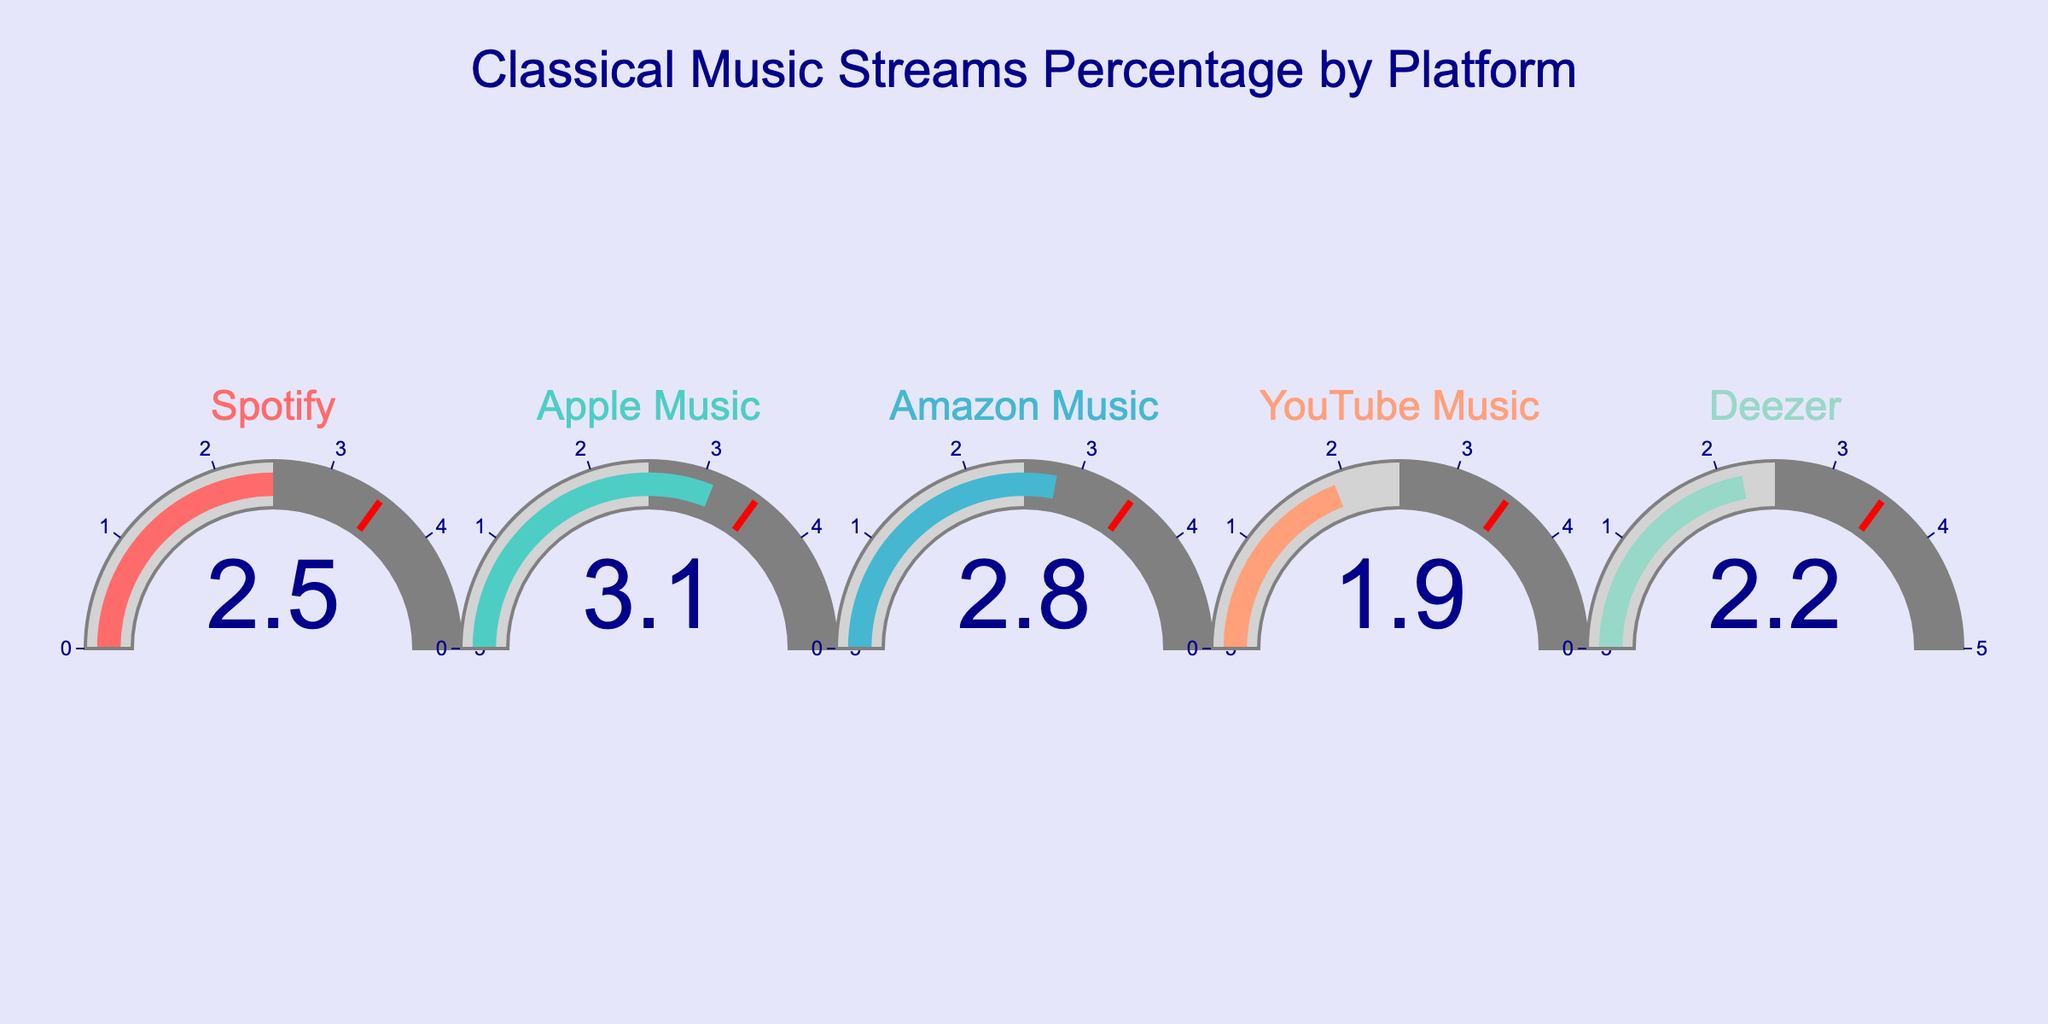what is the title of the figure? The title of the figure is located at the top center, and it clearly states the purpose of the visualization.
Answer: "Classical Music Streams Percentage by Platform" How many platforms are displayed in the figure? The figure contains gauges for individual platforms, each representing classical music stream percentages. You can count them one by one.
Answer: 5 Which platform has the highest percentage of classical music streams? Look at the numbers shown in each gauge. Identify the platform with the highest value.
Answer: Apple Music How much lower is the classical music stream percentage on YouTube Music compared to Apple Music? Find and compare the percentages of YouTube Music and Apple Music. Subtract the YouTube Music percentage from that of Apple Music.
Answer: 1.2% Is there any platform where classical music streams percentage exceeds 3%? Check all gauges to see if any percentage value is greater than 3%.
Answer: Yes, Apple Music What is the overall range of classical music stream percentages for all platforms shown? Identify the minimum and maximum percentages from the gauges to determine the range.
Answer: 1.9% to 3.1% What is the average percentage of classical music streams across all platforms? Sum the percentages of all platforms and divide by the number of platforms (5).
Answer: 2.5% Which platform has the closest percentage to the average percentage of classical music streams? Calculate the average percentage first, then compare each platform's percentage to find the closest value.
Answer: Spotify Compare the classical music stream percentages of Spotify and Deezer: which one is higher? Locate the percentages of both Spotify and Deezer and determine which is larger.
Answer: Spotify Is the percentage of classical music streams on Amazon Music closer to that on YouTube Music or Apple Music? Compare the percentage of Amazon Music with both YouTube Music and Apple Music, and determine which difference is smaller.
Answer: YouTube Music 